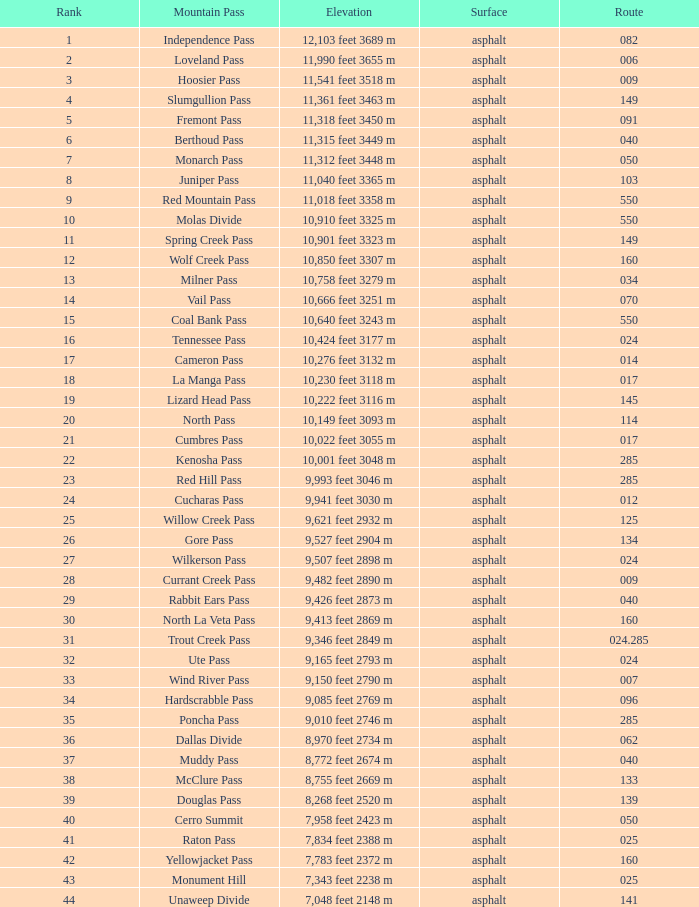What is the Elevation of the mountain on Route 62? 8,970 feet 2734 m. 